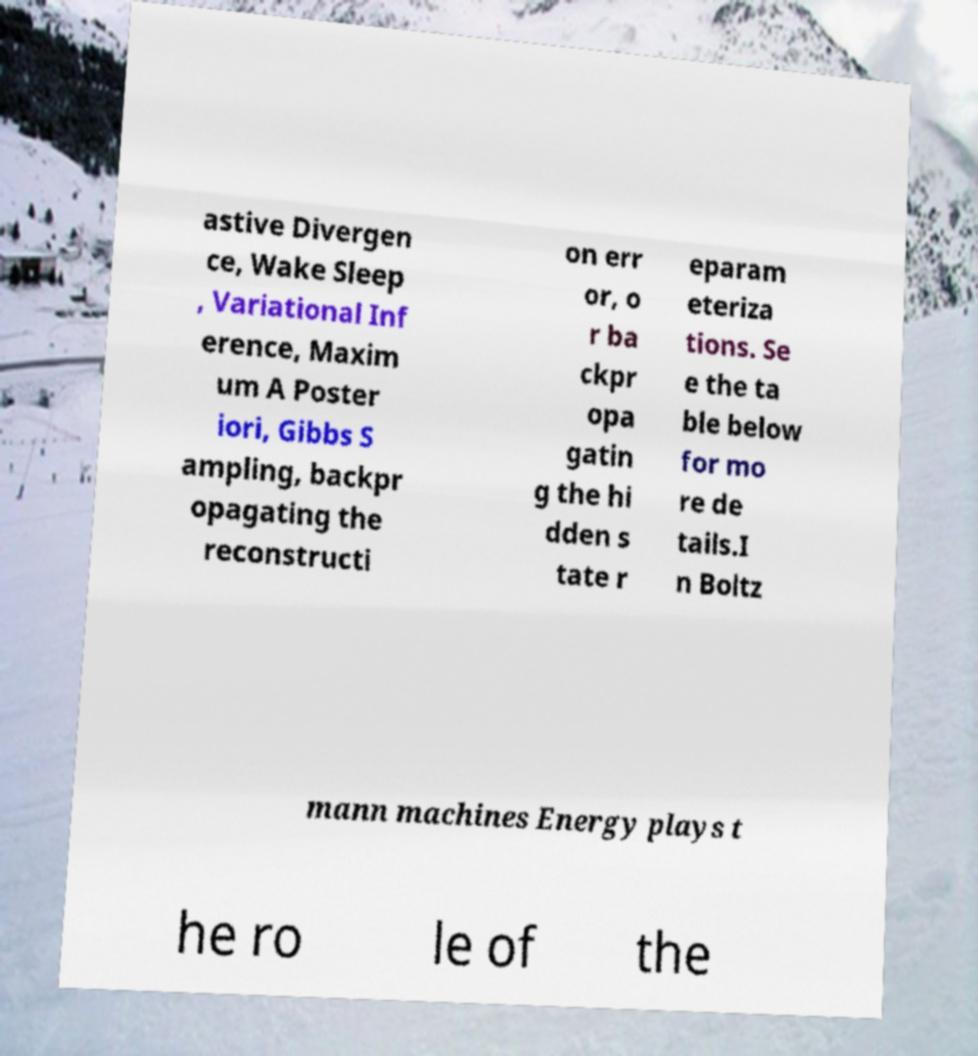Please identify and transcribe the text found in this image. astive Divergen ce, Wake Sleep , Variational Inf erence, Maxim um A Poster iori, Gibbs S ampling, backpr opagating the reconstructi on err or, o r ba ckpr opa gatin g the hi dden s tate r eparam eteriza tions. Se e the ta ble below for mo re de tails.I n Boltz mann machines Energy plays t he ro le of the 